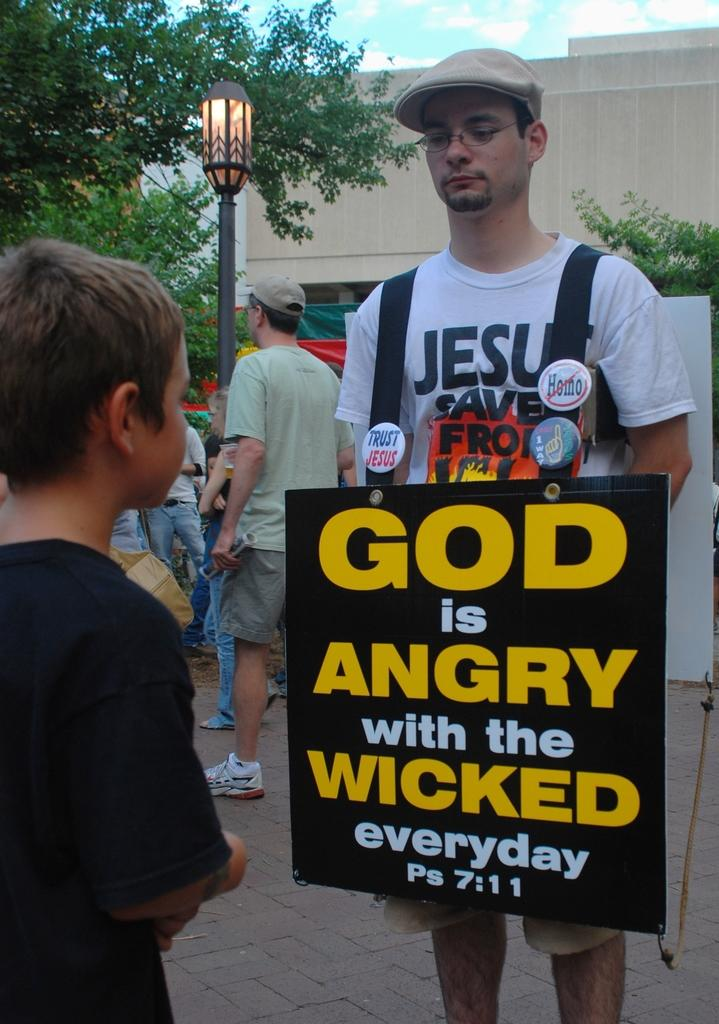What is the man in the image doing? The man is standing with boards in the image. Are there any other people in the image? Yes, there is a group of people standing in the image. What can be seen in the background of the image? The sky is visible in the background of the image. What type of structure is present in the image? There is a building in the image. What else can be seen in the image? There is a pole, a light, and trees in the image. Where are the babies playing in the image? There are no babies present in the image. What type of payment is being made in the image? There is no payment being made in the image. 